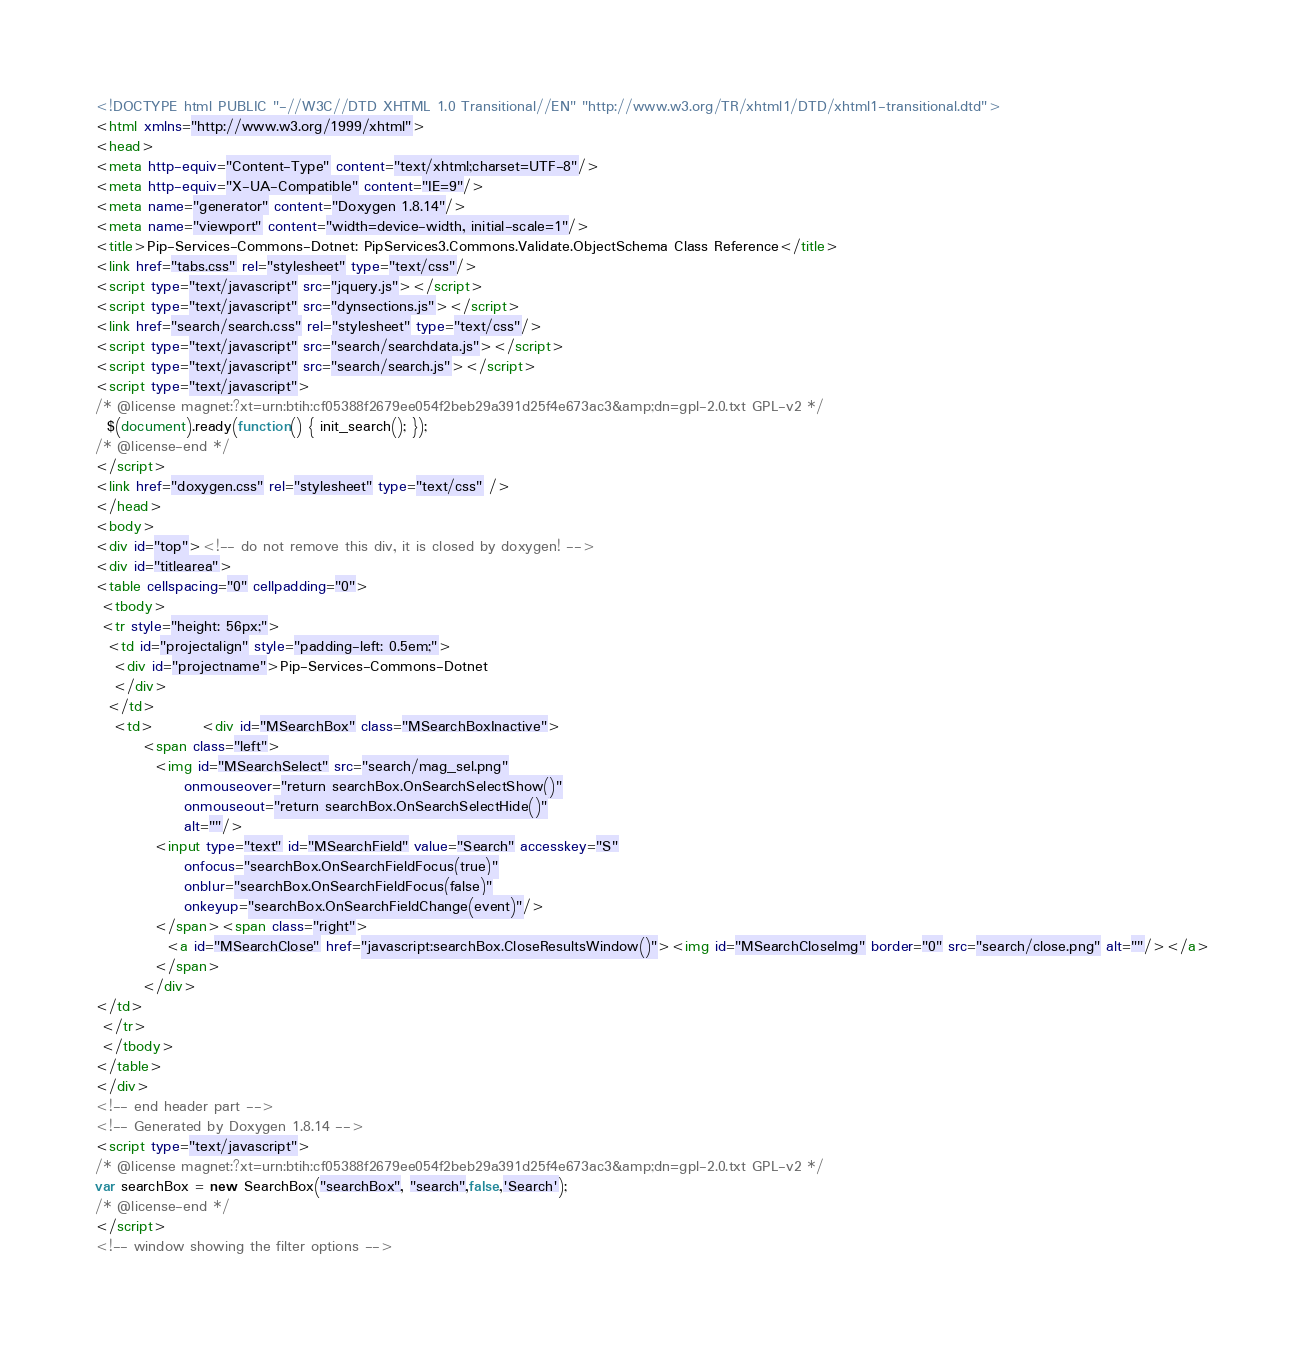<code> <loc_0><loc_0><loc_500><loc_500><_HTML_><!DOCTYPE html PUBLIC "-//W3C//DTD XHTML 1.0 Transitional//EN" "http://www.w3.org/TR/xhtml1/DTD/xhtml1-transitional.dtd">
<html xmlns="http://www.w3.org/1999/xhtml">
<head>
<meta http-equiv="Content-Type" content="text/xhtml;charset=UTF-8"/>
<meta http-equiv="X-UA-Compatible" content="IE=9"/>
<meta name="generator" content="Doxygen 1.8.14"/>
<meta name="viewport" content="width=device-width, initial-scale=1"/>
<title>Pip-Services-Commons-Dotnet: PipServices3.Commons.Validate.ObjectSchema Class Reference</title>
<link href="tabs.css" rel="stylesheet" type="text/css"/>
<script type="text/javascript" src="jquery.js"></script>
<script type="text/javascript" src="dynsections.js"></script>
<link href="search/search.css" rel="stylesheet" type="text/css"/>
<script type="text/javascript" src="search/searchdata.js"></script>
<script type="text/javascript" src="search/search.js"></script>
<script type="text/javascript">
/* @license magnet:?xt=urn:btih:cf05388f2679ee054f2beb29a391d25f4e673ac3&amp;dn=gpl-2.0.txt GPL-v2 */
  $(document).ready(function() { init_search(); });
/* @license-end */
</script>
<link href="doxygen.css" rel="stylesheet" type="text/css" />
</head>
<body>
<div id="top"><!-- do not remove this div, it is closed by doxygen! -->
<div id="titlearea">
<table cellspacing="0" cellpadding="0">
 <tbody>
 <tr style="height: 56px;">
  <td id="projectalign" style="padding-left: 0.5em;">
   <div id="projectname">Pip-Services-Commons-Dotnet
   </div>
  </td>
   <td>        <div id="MSearchBox" class="MSearchBoxInactive">
        <span class="left">
          <img id="MSearchSelect" src="search/mag_sel.png"
               onmouseover="return searchBox.OnSearchSelectShow()"
               onmouseout="return searchBox.OnSearchSelectHide()"
               alt=""/>
          <input type="text" id="MSearchField" value="Search" accesskey="S"
               onfocus="searchBox.OnSearchFieldFocus(true)" 
               onblur="searchBox.OnSearchFieldFocus(false)" 
               onkeyup="searchBox.OnSearchFieldChange(event)"/>
          </span><span class="right">
            <a id="MSearchClose" href="javascript:searchBox.CloseResultsWindow()"><img id="MSearchCloseImg" border="0" src="search/close.png" alt=""/></a>
          </span>
        </div>
</td>
 </tr>
 </tbody>
</table>
</div>
<!-- end header part -->
<!-- Generated by Doxygen 1.8.14 -->
<script type="text/javascript">
/* @license magnet:?xt=urn:btih:cf05388f2679ee054f2beb29a391d25f4e673ac3&amp;dn=gpl-2.0.txt GPL-v2 */
var searchBox = new SearchBox("searchBox", "search",false,'Search');
/* @license-end */
</script>
<!-- window showing the filter options --></code> 